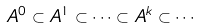Convert formula to latex. <formula><loc_0><loc_0><loc_500><loc_500>A ^ { 0 } \subset A ^ { 1 } \subset \cdots \subset A ^ { k } \subset \cdots</formula> 